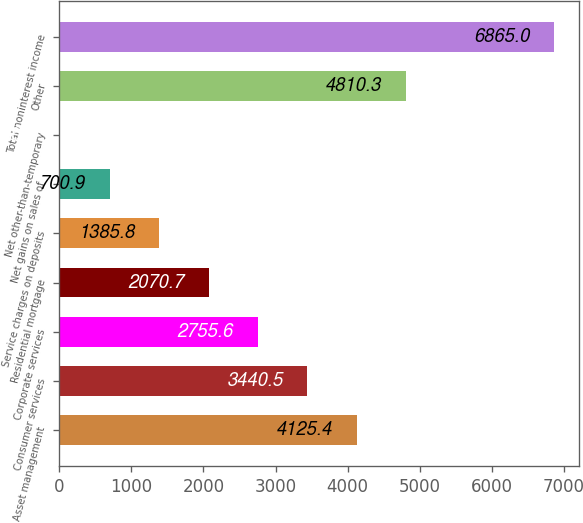Convert chart to OTSL. <chart><loc_0><loc_0><loc_500><loc_500><bar_chart><fcel>Asset management<fcel>Consumer services<fcel>Corporate services<fcel>Residential mortgage<fcel>Service charges on deposits<fcel>Net gains on sales of<fcel>Net other-than-temporary<fcel>Other<fcel>Total noninterest income<nl><fcel>4125.4<fcel>3440.5<fcel>2755.6<fcel>2070.7<fcel>1385.8<fcel>700.9<fcel>16<fcel>4810.3<fcel>6865<nl></chart> 